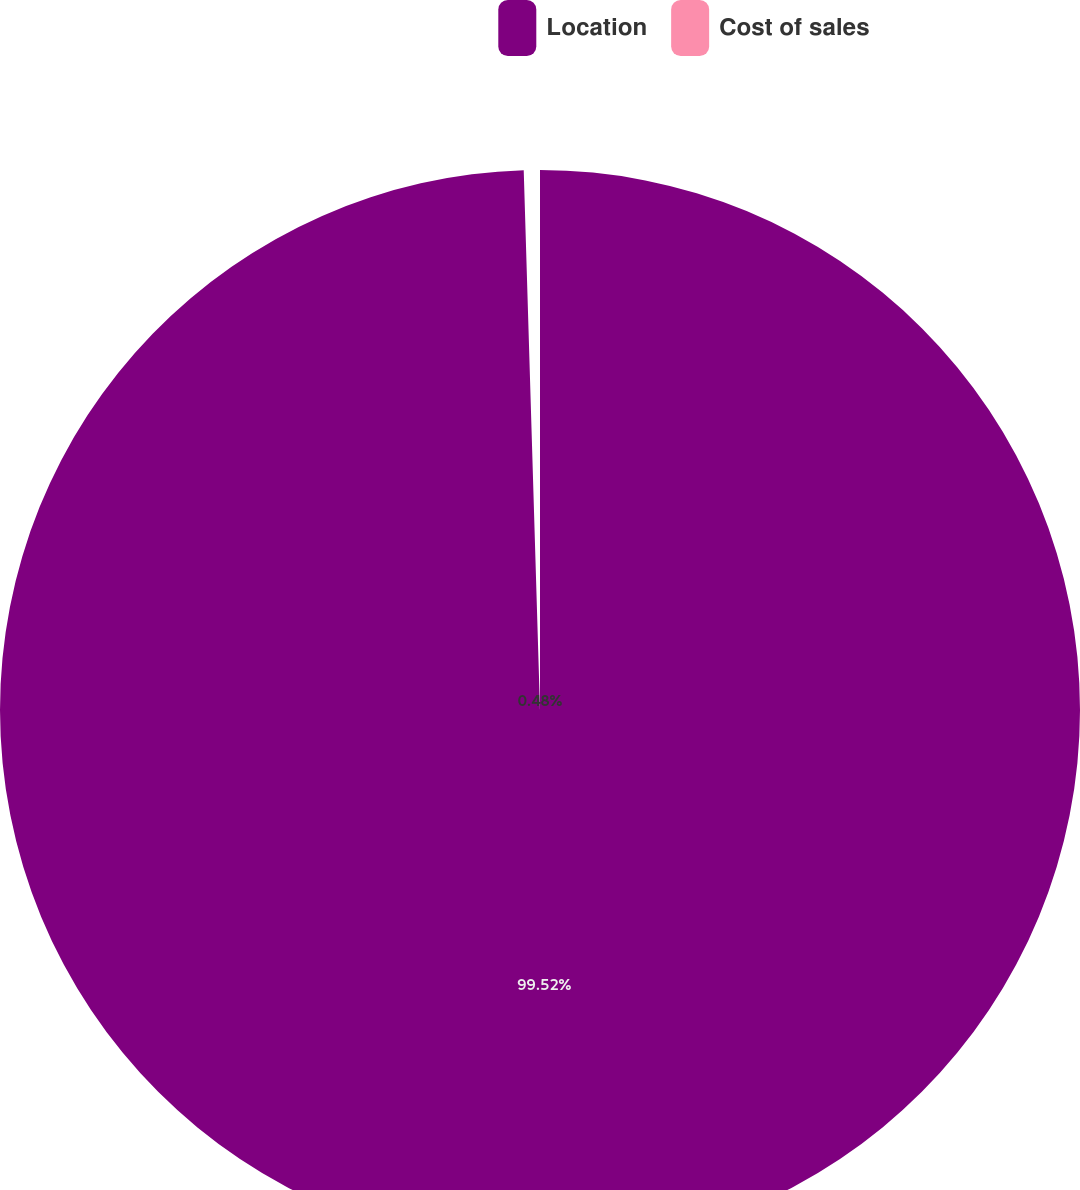Convert chart. <chart><loc_0><loc_0><loc_500><loc_500><pie_chart><fcel>Location<fcel>Cost of sales<nl><fcel>99.52%<fcel>0.48%<nl></chart> 